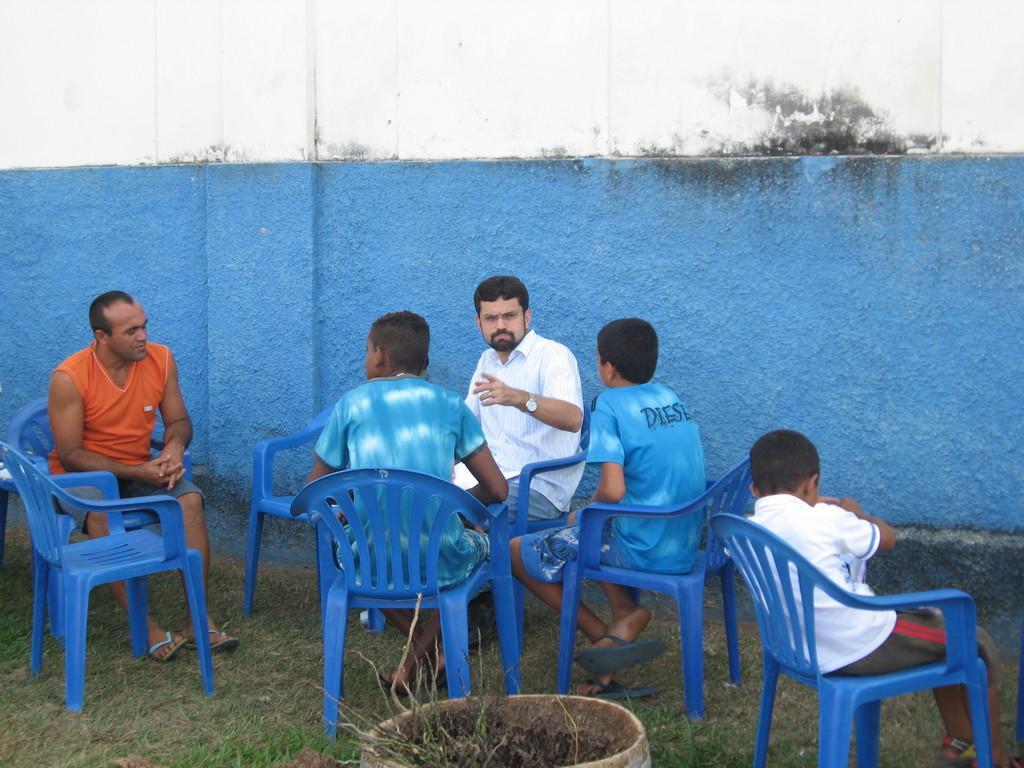In one or two sentences, can you explain what this image depicts? In this picture few people sitting on blue colored chairs. Of them two are men and three are boys. They are located on grass patches. The wall beside them is painted in blue. 